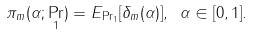<formula> <loc_0><loc_0><loc_500><loc_500>\pi _ { m } ( \alpha ; \Pr _ { 1 } ) = E _ { \Pr _ { 1 } } [ \delta _ { m } ( \alpha ) ] , \ \alpha \in [ 0 , 1 ] .</formula> 